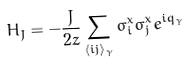Convert formula to latex. <formula><loc_0><loc_0><loc_500><loc_500>H _ { J } = - \frac { J } { 2 z } \sum _ { \langle i j \rangle _ { \gamma } } \sigma ^ { x } _ { i } \sigma ^ { x } _ { j } e ^ { i q _ { \gamma } }</formula> 